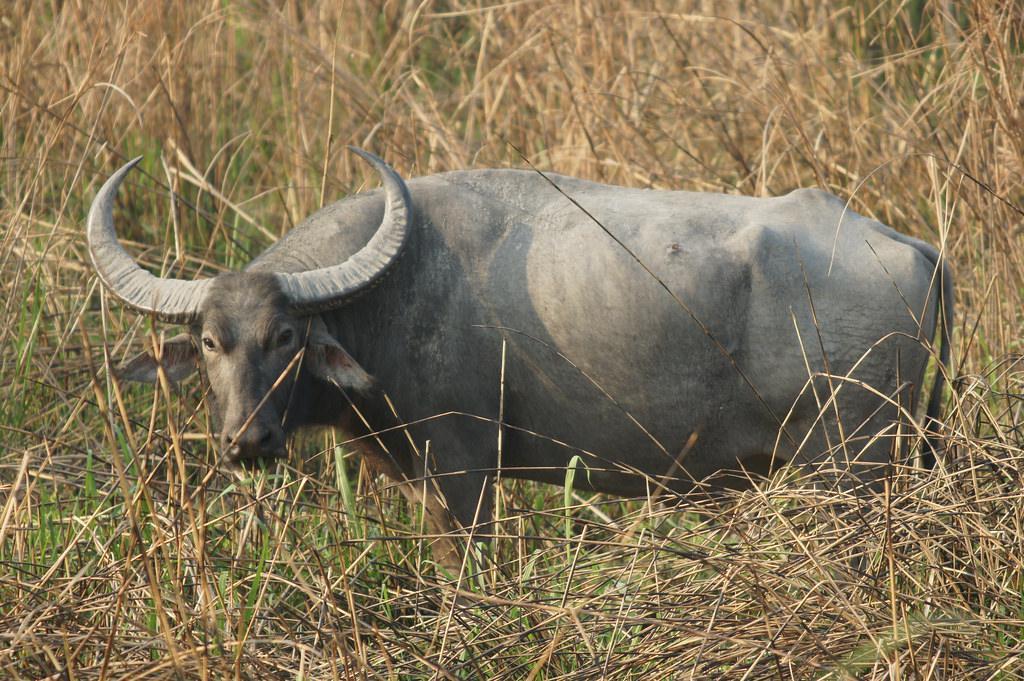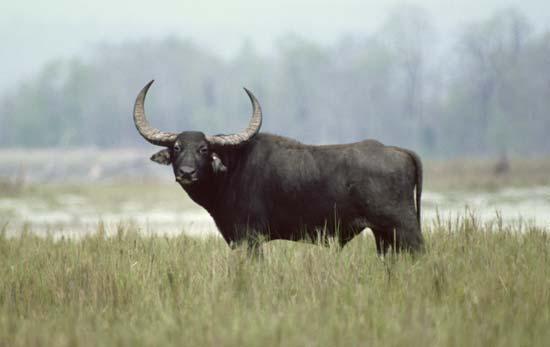The first image is the image on the left, the second image is the image on the right. Analyze the images presented: Is the assertion "Two cows are standing in a watery area." valid? Answer yes or no. No. The first image is the image on the left, the second image is the image on the right. Analyze the images presented: Is the assertion "An image shows exactly one water buffalo standing on muddy, wet ground." valid? Answer yes or no. No. 